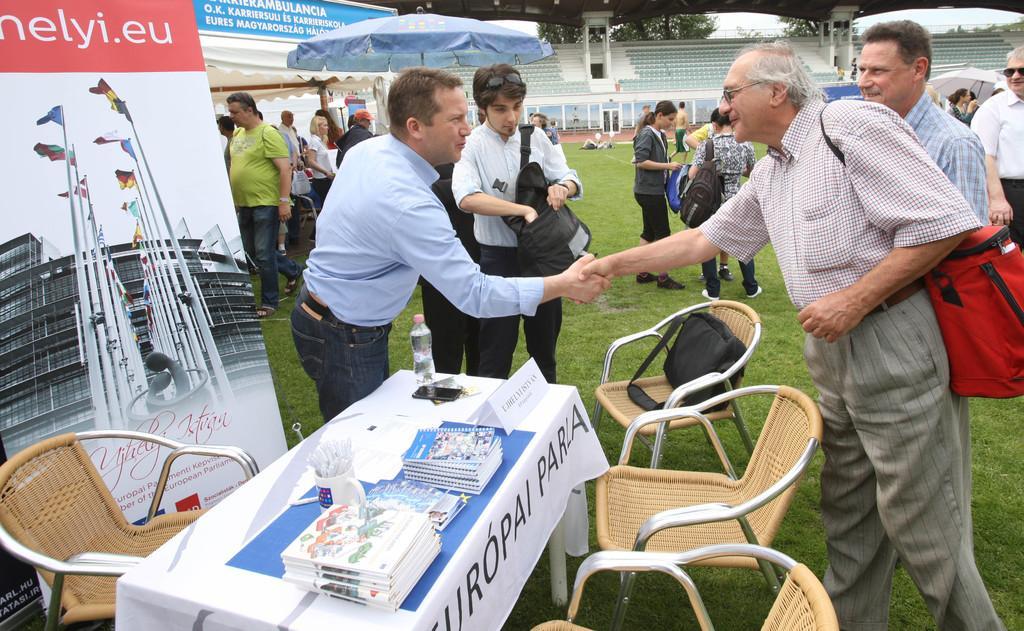Please provide a concise description of this image. There are two persons her giving shake hand. Behind them there are many people,tent,hoarding,trees. On the left there is a hoarding,table and chairs. On the table we can see books and a water bottle. 